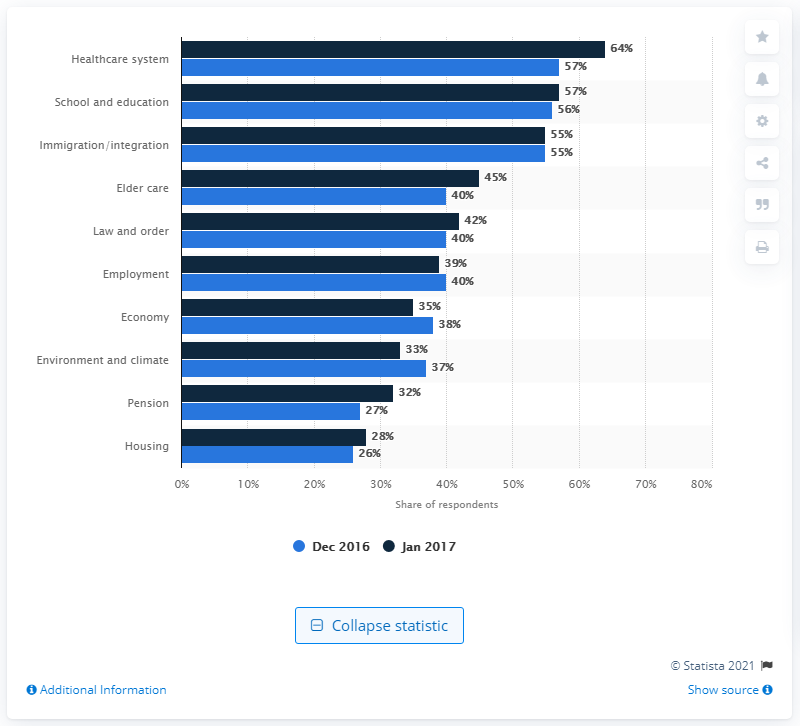Outline some significant characteristics in this image. The difference between 2016 and 2017 in housing is that there was a significant increase in housing prices in 2017 compared to the previous year. In Sweden, the highest political issue is the healthcare system. 